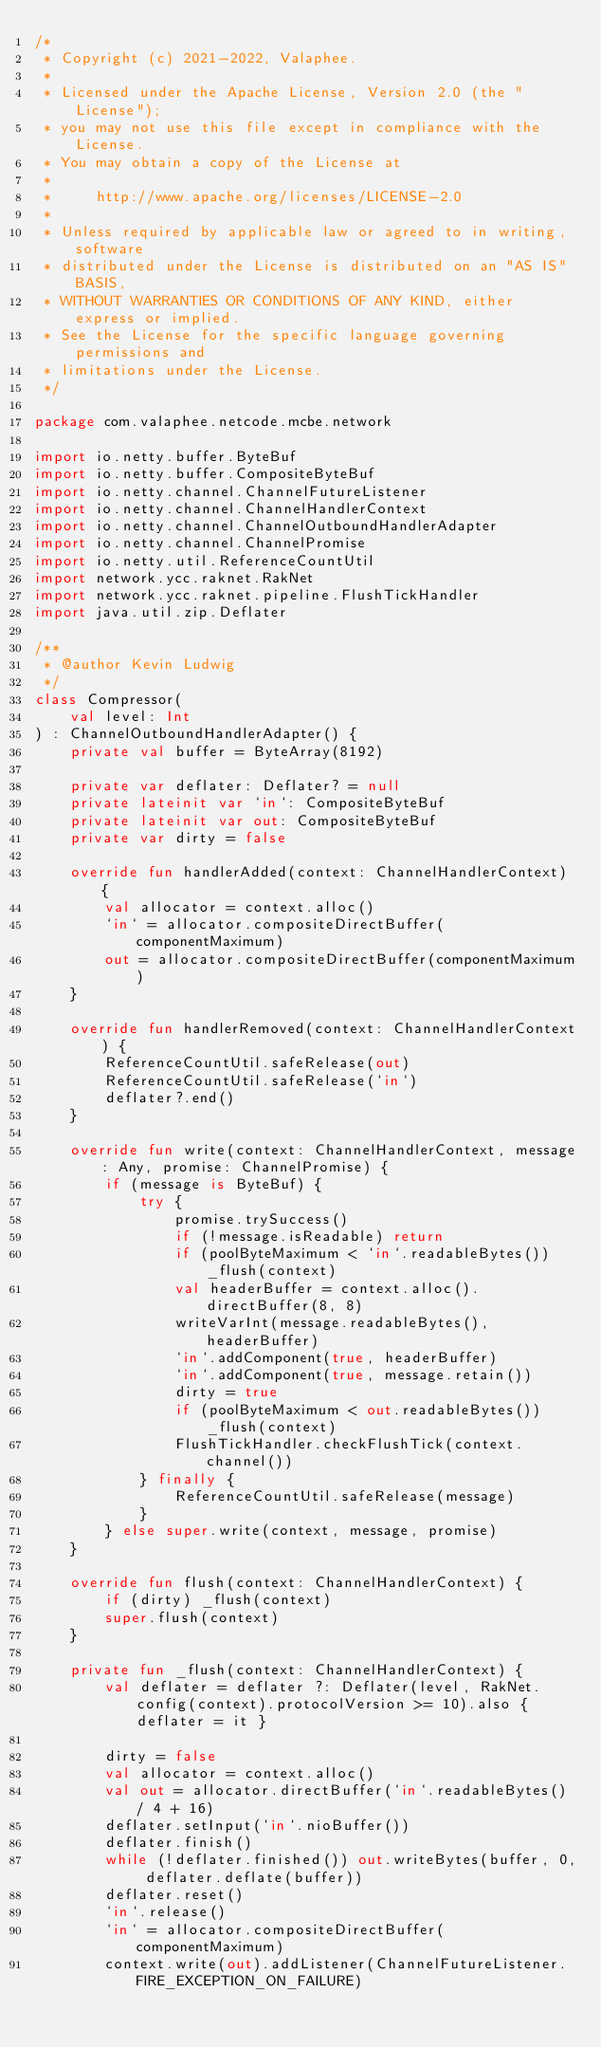<code> <loc_0><loc_0><loc_500><loc_500><_Kotlin_>/*
 * Copyright (c) 2021-2022, Valaphee.
 *
 * Licensed under the Apache License, Version 2.0 (the "License");
 * you may not use this file except in compliance with the License.
 * You may obtain a copy of the License at
 *
 *     http://www.apache.org/licenses/LICENSE-2.0
 *
 * Unless required by applicable law or agreed to in writing, software
 * distributed under the License is distributed on an "AS IS" BASIS,
 * WITHOUT WARRANTIES OR CONDITIONS OF ANY KIND, either express or implied.
 * See the License for the specific language governing permissions and
 * limitations under the License.
 */

package com.valaphee.netcode.mcbe.network

import io.netty.buffer.ByteBuf
import io.netty.buffer.CompositeByteBuf
import io.netty.channel.ChannelFutureListener
import io.netty.channel.ChannelHandlerContext
import io.netty.channel.ChannelOutboundHandlerAdapter
import io.netty.channel.ChannelPromise
import io.netty.util.ReferenceCountUtil
import network.ycc.raknet.RakNet
import network.ycc.raknet.pipeline.FlushTickHandler
import java.util.zip.Deflater

/**
 * @author Kevin Ludwig
 */
class Compressor(
    val level: Int
) : ChannelOutboundHandlerAdapter() {
    private val buffer = ByteArray(8192)

    private var deflater: Deflater? = null
    private lateinit var `in`: CompositeByteBuf
    private lateinit var out: CompositeByteBuf
    private var dirty = false

    override fun handlerAdded(context: ChannelHandlerContext) {
        val allocator = context.alloc()
        `in` = allocator.compositeDirectBuffer(componentMaximum)
        out = allocator.compositeDirectBuffer(componentMaximum)
    }

    override fun handlerRemoved(context: ChannelHandlerContext) {
        ReferenceCountUtil.safeRelease(out)
        ReferenceCountUtil.safeRelease(`in`)
        deflater?.end()
    }

    override fun write(context: ChannelHandlerContext, message: Any, promise: ChannelPromise) {
        if (message is ByteBuf) {
            try {
                promise.trySuccess()
                if (!message.isReadable) return
                if (poolByteMaximum < `in`.readableBytes()) _flush(context)
                val headerBuffer = context.alloc().directBuffer(8, 8)
                writeVarInt(message.readableBytes(), headerBuffer)
                `in`.addComponent(true, headerBuffer)
                `in`.addComponent(true, message.retain())
                dirty = true
                if (poolByteMaximum < out.readableBytes()) _flush(context)
                FlushTickHandler.checkFlushTick(context.channel())
            } finally {
                ReferenceCountUtil.safeRelease(message)
            }
        } else super.write(context, message, promise)
    }

    override fun flush(context: ChannelHandlerContext) {
        if (dirty) _flush(context)
        super.flush(context)
    }

    private fun _flush(context: ChannelHandlerContext) {
        val deflater = deflater ?: Deflater(level, RakNet.config(context).protocolVersion >= 10).also { deflater = it }

        dirty = false
        val allocator = context.alloc()
        val out = allocator.directBuffer(`in`.readableBytes() / 4 + 16)
        deflater.setInput(`in`.nioBuffer())
        deflater.finish()
        while (!deflater.finished()) out.writeBytes(buffer, 0, deflater.deflate(buffer))
        deflater.reset()
        `in`.release()
        `in` = allocator.compositeDirectBuffer(componentMaximum)
        context.write(out).addListener(ChannelFutureListener.FIRE_EXCEPTION_ON_FAILURE)</code> 